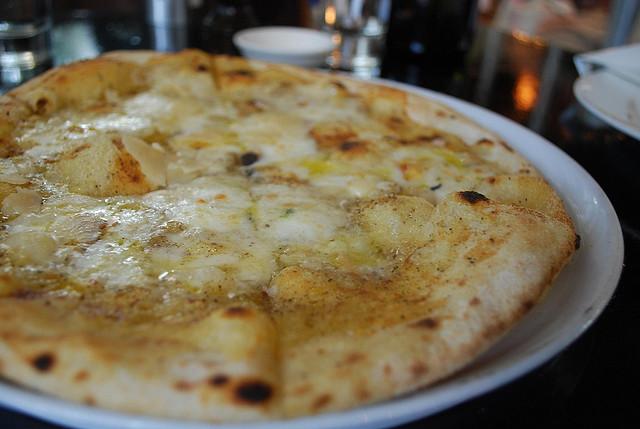Is the pizza in slices?
Give a very brief answer. Yes. What kind of food is this?
Quick response, please. Pizza. Is there any sauce on the pizza?
Short answer required. No. What topping is on the pizza?
Answer briefly. Cheese. 